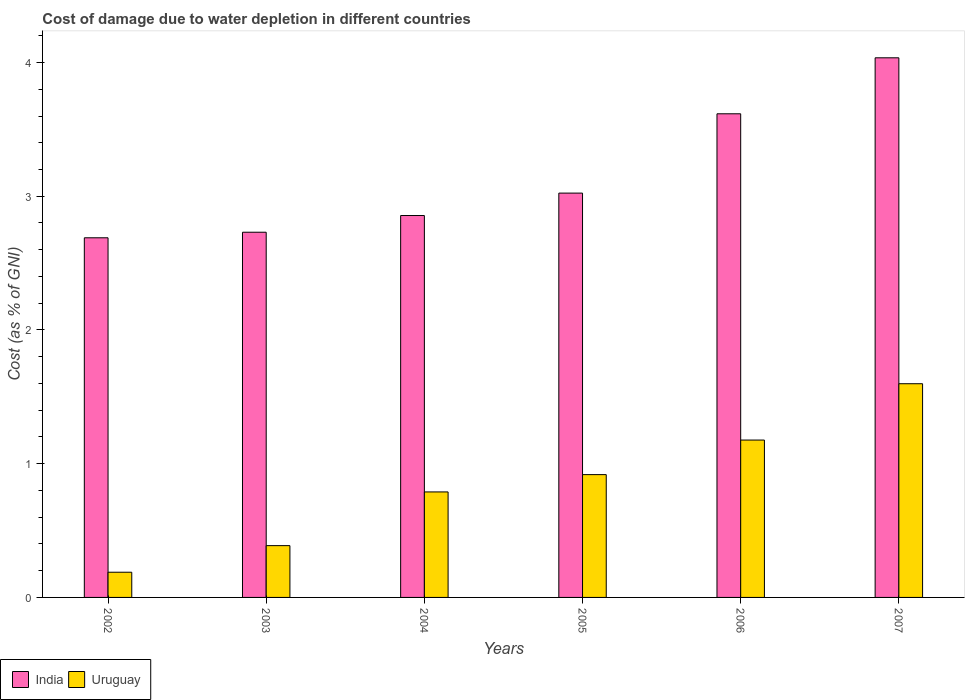How many different coloured bars are there?
Your answer should be very brief. 2. Are the number of bars on each tick of the X-axis equal?
Provide a short and direct response. Yes. How many bars are there on the 2nd tick from the left?
Keep it short and to the point. 2. How many bars are there on the 3rd tick from the right?
Provide a succinct answer. 2. What is the cost of damage caused due to water depletion in Uruguay in 2004?
Offer a very short reply. 0.79. Across all years, what is the maximum cost of damage caused due to water depletion in Uruguay?
Give a very brief answer. 1.6. Across all years, what is the minimum cost of damage caused due to water depletion in India?
Offer a terse response. 2.69. What is the total cost of damage caused due to water depletion in Uruguay in the graph?
Ensure brevity in your answer.  5.06. What is the difference between the cost of damage caused due to water depletion in Uruguay in 2003 and that in 2006?
Keep it short and to the point. -0.79. What is the difference between the cost of damage caused due to water depletion in India in 2002 and the cost of damage caused due to water depletion in Uruguay in 2004?
Keep it short and to the point. 1.9. What is the average cost of damage caused due to water depletion in India per year?
Your response must be concise. 3.16. In the year 2004, what is the difference between the cost of damage caused due to water depletion in India and cost of damage caused due to water depletion in Uruguay?
Offer a very short reply. 2.07. In how many years, is the cost of damage caused due to water depletion in India greater than 3.6 %?
Give a very brief answer. 2. What is the ratio of the cost of damage caused due to water depletion in India in 2002 to that in 2004?
Keep it short and to the point. 0.94. What is the difference between the highest and the second highest cost of damage caused due to water depletion in Uruguay?
Keep it short and to the point. 0.42. What is the difference between the highest and the lowest cost of damage caused due to water depletion in Uruguay?
Offer a very short reply. 1.41. Is the sum of the cost of damage caused due to water depletion in Uruguay in 2005 and 2006 greater than the maximum cost of damage caused due to water depletion in India across all years?
Make the answer very short. No. What does the 2nd bar from the left in 2004 represents?
Give a very brief answer. Uruguay. What does the 1st bar from the right in 2006 represents?
Keep it short and to the point. Uruguay. What is the difference between two consecutive major ticks on the Y-axis?
Give a very brief answer. 1. Are the values on the major ticks of Y-axis written in scientific E-notation?
Offer a terse response. No. Does the graph contain any zero values?
Offer a very short reply. No. Does the graph contain grids?
Give a very brief answer. No. How are the legend labels stacked?
Your response must be concise. Horizontal. What is the title of the graph?
Ensure brevity in your answer.  Cost of damage due to water depletion in different countries. Does "Liechtenstein" appear as one of the legend labels in the graph?
Give a very brief answer. No. What is the label or title of the X-axis?
Provide a short and direct response. Years. What is the label or title of the Y-axis?
Provide a short and direct response. Cost (as % of GNI). What is the Cost (as % of GNI) of India in 2002?
Your answer should be very brief. 2.69. What is the Cost (as % of GNI) of Uruguay in 2002?
Give a very brief answer. 0.19. What is the Cost (as % of GNI) of India in 2003?
Your answer should be compact. 2.73. What is the Cost (as % of GNI) in Uruguay in 2003?
Offer a very short reply. 0.39. What is the Cost (as % of GNI) in India in 2004?
Offer a very short reply. 2.86. What is the Cost (as % of GNI) in Uruguay in 2004?
Keep it short and to the point. 0.79. What is the Cost (as % of GNI) in India in 2005?
Offer a very short reply. 3.02. What is the Cost (as % of GNI) of Uruguay in 2005?
Provide a short and direct response. 0.92. What is the Cost (as % of GNI) of India in 2006?
Ensure brevity in your answer.  3.62. What is the Cost (as % of GNI) in Uruguay in 2006?
Provide a succinct answer. 1.18. What is the Cost (as % of GNI) in India in 2007?
Offer a very short reply. 4.04. What is the Cost (as % of GNI) in Uruguay in 2007?
Provide a short and direct response. 1.6. Across all years, what is the maximum Cost (as % of GNI) of India?
Keep it short and to the point. 4.04. Across all years, what is the maximum Cost (as % of GNI) of Uruguay?
Provide a short and direct response. 1.6. Across all years, what is the minimum Cost (as % of GNI) in India?
Your answer should be compact. 2.69. Across all years, what is the minimum Cost (as % of GNI) in Uruguay?
Provide a succinct answer. 0.19. What is the total Cost (as % of GNI) in India in the graph?
Your answer should be compact. 18.95. What is the total Cost (as % of GNI) in Uruguay in the graph?
Keep it short and to the point. 5.06. What is the difference between the Cost (as % of GNI) in India in 2002 and that in 2003?
Ensure brevity in your answer.  -0.04. What is the difference between the Cost (as % of GNI) in Uruguay in 2002 and that in 2003?
Provide a short and direct response. -0.2. What is the difference between the Cost (as % of GNI) in India in 2002 and that in 2004?
Provide a short and direct response. -0.17. What is the difference between the Cost (as % of GNI) in Uruguay in 2002 and that in 2004?
Make the answer very short. -0.6. What is the difference between the Cost (as % of GNI) of India in 2002 and that in 2005?
Provide a succinct answer. -0.33. What is the difference between the Cost (as % of GNI) of Uruguay in 2002 and that in 2005?
Provide a succinct answer. -0.73. What is the difference between the Cost (as % of GNI) of India in 2002 and that in 2006?
Offer a very short reply. -0.93. What is the difference between the Cost (as % of GNI) in Uruguay in 2002 and that in 2006?
Provide a short and direct response. -0.99. What is the difference between the Cost (as % of GNI) of India in 2002 and that in 2007?
Offer a terse response. -1.35. What is the difference between the Cost (as % of GNI) in Uruguay in 2002 and that in 2007?
Provide a succinct answer. -1.41. What is the difference between the Cost (as % of GNI) of India in 2003 and that in 2004?
Make the answer very short. -0.12. What is the difference between the Cost (as % of GNI) of Uruguay in 2003 and that in 2004?
Offer a terse response. -0.4. What is the difference between the Cost (as % of GNI) of India in 2003 and that in 2005?
Offer a very short reply. -0.29. What is the difference between the Cost (as % of GNI) in Uruguay in 2003 and that in 2005?
Make the answer very short. -0.53. What is the difference between the Cost (as % of GNI) in India in 2003 and that in 2006?
Keep it short and to the point. -0.89. What is the difference between the Cost (as % of GNI) in Uruguay in 2003 and that in 2006?
Offer a very short reply. -0.79. What is the difference between the Cost (as % of GNI) in India in 2003 and that in 2007?
Make the answer very short. -1.3. What is the difference between the Cost (as % of GNI) of Uruguay in 2003 and that in 2007?
Offer a very short reply. -1.21. What is the difference between the Cost (as % of GNI) in India in 2004 and that in 2005?
Offer a very short reply. -0.17. What is the difference between the Cost (as % of GNI) in Uruguay in 2004 and that in 2005?
Offer a terse response. -0.13. What is the difference between the Cost (as % of GNI) in India in 2004 and that in 2006?
Keep it short and to the point. -0.76. What is the difference between the Cost (as % of GNI) in Uruguay in 2004 and that in 2006?
Ensure brevity in your answer.  -0.39. What is the difference between the Cost (as % of GNI) in India in 2004 and that in 2007?
Ensure brevity in your answer.  -1.18. What is the difference between the Cost (as % of GNI) in Uruguay in 2004 and that in 2007?
Provide a succinct answer. -0.81. What is the difference between the Cost (as % of GNI) in India in 2005 and that in 2006?
Offer a very short reply. -0.59. What is the difference between the Cost (as % of GNI) in Uruguay in 2005 and that in 2006?
Ensure brevity in your answer.  -0.26. What is the difference between the Cost (as % of GNI) in India in 2005 and that in 2007?
Offer a very short reply. -1.01. What is the difference between the Cost (as % of GNI) of Uruguay in 2005 and that in 2007?
Provide a succinct answer. -0.68. What is the difference between the Cost (as % of GNI) of India in 2006 and that in 2007?
Ensure brevity in your answer.  -0.42. What is the difference between the Cost (as % of GNI) in Uruguay in 2006 and that in 2007?
Give a very brief answer. -0.42. What is the difference between the Cost (as % of GNI) of India in 2002 and the Cost (as % of GNI) of Uruguay in 2003?
Ensure brevity in your answer.  2.3. What is the difference between the Cost (as % of GNI) in India in 2002 and the Cost (as % of GNI) in Uruguay in 2004?
Keep it short and to the point. 1.9. What is the difference between the Cost (as % of GNI) in India in 2002 and the Cost (as % of GNI) in Uruguay in 2005?
Keep it short and to the point. 1.77. What is the difference between the Cost (as % of GNI) in India in 2002 and the Cost (as % of GNI) in Uruguay in 2006?
Your answer should be very brief. 1.51. What is the difference between the Cost (as % of GNI) in India in 2002 and the Cost (as % of GNI) in Uruguay in 2007?
Offer a very short reply. 1.09. What is the difference between the Cost (as % of GNI) in India in 2003 and the Cost (as % of GNI) in Uruguay in 2004?
Offer a very short reply. 1.94. What is the difference between the Cost (as % of GNI) in India in 2003 and the Cost (as % of GNI) in Uruguay in 2005?
Make the answer very short. 1.81. What is the difference between the Cost (as % of GNI) of India in 2003 and the Cost (as % of GNI) of Uruguay in 2006?
Make the answer very short. 1.55. What is the difference between the Cost (as % of GNI) of India in 2003 and the Cost (as % of GNI) of Uruguay in 2007?
Make the answer very short. 1.13. What is the difference between the Cost (as % of GNI) in India in 2004 and the Cost (as % of GNI) in Uruguay in 2005?
Make the answer very short. 1.94. What is the difference between the Cost (as % of GNI) in India in 2004 and the Cost (as % of GNI) in Uruguay in 2006?
Provide a succinct answer. 1.68. What is the difference between the Cost (as % of GNI) of India in 2004 and the Cost (as % of GNI) of Uruguay in 2007?
Your answer should be very brief. 1.26. What is the difference between the Cost (as % of GNI) of India in 2005 and the Cost (as % of GNI) of Uruguay in 2006?
Offer a very short reply. 1.85. What is the difference between the Cost (as % of GNI) in India in 2005 and the Cost (as % of GNI) in Uruguay in 2007?
Keep it short and to the point. 1.43. What is the difference between the Cost (as % of GNI) of India in 2006 and the Cost (as % of GNI) of Uruguay in 2007?
Provide a succinct answer. 2.02. What is the average Cost (as % of GNI) of India per year?
Your answer should be compact. 3.16. What is the average Cost (as % of GNI) in Uruguay per year?
Your answer should be compact. 0.84. In the year 2002, what is the difference between the Cost (as % of GNI) in India and Cost (as % of GNI) in Uruguay?
Keep it short and to the point. 2.5. In the year 2003, what is the difference between the Cost (as % of GNI) in India and Cost (as % of GNI) in Uruguay?
Make the answer very short. 2.34. In the year 2004, what is the difference between the Cost (as % of GNI) of India and Cost (as % of GNI) of Uruguay?
Provide a short and direct response. 2.07. In the year 2005, what is the difference between the Cost (as % of GNI) in India and Cost (as % of GNI) in Uruguay?
Offer a very short reply. 2.11. In the year 2006, what is the difference between the Cost (as % of GNI) in India and Cost (as % of GNI) in Uruguay?
Provide a short and direct response. 2.44. In the year 2007, what is the difference between the Cost (as % of GNI) of India and Cost (as % of GNI) of Uruguay?
Your answer should be compact. 2.44. What is the ratio of the Cost (as % of GNI) in India in 2002 to that in 2003?
Ensure brevity in your answer.  0.98. What is the ratio of the Cost (as % of GNI) of Uruguay in 2002 to that in 2003?
Provide a short and direct response. 0.49. What is the ratio of the Cost (as % of GNI) of India in 2002 to that in 2004?
Offer a terse response. 0.94. What is the ratio of the Cost (as % of GNI) of Uruguay in 2002 to that in 2004?
Make the answer very short. 0.24. What is the ratio of the Cost (as % of GNI) of India in 2002 to that in 2005?
Give a very brief answer. 0.89. What is the ratio of the Cost (as % of GNI) of Uruguay in 2002 to that in 2005?
Offer a terse response. 0.21. What is the ratio of the Cost (as % of GNI) of India in 2002 to that in 2006?
Your answer should be very brief. 0.74. What is the ratio of the Cost (as % of GNI) of Uruguay in 2002 to that in 2006?
Provide a succinct answer. 0.16. What is the ratio of the Cost (as % of GNI) in India in 2002 to that in 2007?
Offer a terse response. 0.67. What is the ratio of the Cost (as % of GNI) of Uruguay in 2002 to that in 2007?
Provide a succinct answer. 0.12. What is the ratio of the Cost (as % of GNI) of India in 2003 to that in 2004?
Your answer should be compact. 0.96. What is the ratio of the Cost (as % of GNI) of Uruguay in 2003 to that in 2004?
Offer a terse response. 0.49. What is the ratio of the Cost (as % of GNI) in India in 2003 to that in 2005?
Your answer should be very brief. 0.9. What is the ratio of the Cost (as % of GNI) in Uruguay in 2003 to that in 2005?
Provide a succinct answer. 0.42. What is the ratio of the Cost (as % of GNI) of India in 2003 to that in 2006?
Make the answer very short. 0.76. What is the ratio of the Cost (as % of GNI) of Uruguay in 2003 to that in 2006?
Provide a succinct answer. 0.33. What is the ratio of the Cost (as % of GNI) of India in 2003 to that in 2007?
Offer a terse response. 0.68. What is the ratio of the Cost (as % of GNI) in Uruguay in 2003 to that in 2007?
Your answer should be compact. 0.24. What is the ratio of the Cost (as % of GNI) in India in 2004 to that in 2005?
Ensure brevity in your answer.  0.94. What is the ratio of the Cost (as % of GNI) in Uruguay in 2004 to that in 2005?
Give a very brief answer. 0.86. What is the ratio of the Cost (as % of GNI) of India in 2004 to that in 2006?
Offer a terse response. 0.79. What is the ratio of the Cost (as % of GNI) of Uruguay in 2004 to that in 2006?
Your answer should be very brief. 0.67. What is the ratio of the Cost (as % of GNI) in India in 2004 to that in 2007?
Provide a succinct answer. 0.71. What is the ratio of the Cost (as % of GNI) of Uruguay in 2004 to that in 2007?
Your answer should be compact. 0.49. What is the ratio of the Cost (as % of GNI) in India in 2005 to that in 2006?
Provide a succinct answer. 0.84. What is the ratio of the Cost (as % of GNI) in Uruguay in 2005 to that in 2006?
Ensure brevity in your answer.  0.78. What is the ratio of the Cost (as % of GNI) in India in 2005 to that in 2007?
Provide a short and direct response. 0.75. What is the ratio of the Cost (as % of GNI) of Uruguay in 2005 to that in 2007?
Offer a very short reply. 0.57. What is the ratio of the Cost (as % of GNI) in India in 2006 to that in 2007?
Give a very brief answer. 0.9. What is the ratio of the Cost (as % of GNI) of Uruguay in 2006 to that in 2007?
Ensure brevity in your answer.  0.74. What is the difference between the highest and the second highest Cost (as % of GNI) in India?
Your response must be concise. 0.42. What is the difference between the highest and the second highest Cost (as % of GNI) in Uruguay?
Offer a terse response. 0.42. What is the difference between the highest and the lowest Cost (as % of GNI) of India?
Your answer should be compact. 1.35. What is the difference between the highest and the lowest Cost (as % of GNI) in Uruguay?
Your answer should be very brief. 1.41. 